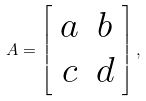Convert formula to latex. <formula><loc_0><loc_0><loc_500><loc_500>A = \left [ \begin{array} { c c } a & b \\ c & d \end{array} \right ] ,</formula> 